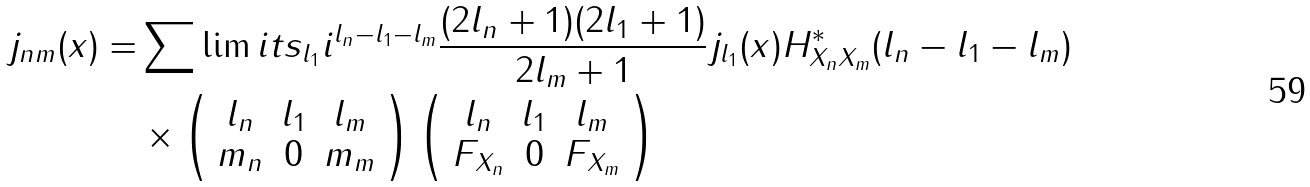<formula> <loc_0><loc_0><loc_500><loc_500>j _ { n m } ( x ) = & \sum \lim i t s _ { l _ { 1 } } i ^ { l _ { n } - l _ { 1 } - l _ { m } } \frac { ( 2 l _ { n } + 1 ) ( 2 l _ { 1 } + 1 ) } { 2 l _ { m } + 1 } j _ { l _ { 1 } } ( x ) H _ { X _ { n } X _ { m } } ^ { * } ( l _ { n } - l _ { 1 } - l _ { m } ) \\ & \times \left ( \begin{array} { c c c } l _ { n } & l _ { 1 } & l _ { m } \\ m _ { n } & 0 & m _ { m } \end{array} \right ) \left ( \begin{array} { c c c } l _ { n } & l _ { 1 } & l _ { m } \\ F _ { X _ { n } } & 0 & F _ { X _ { m } } \end{array} \right )</formula> 